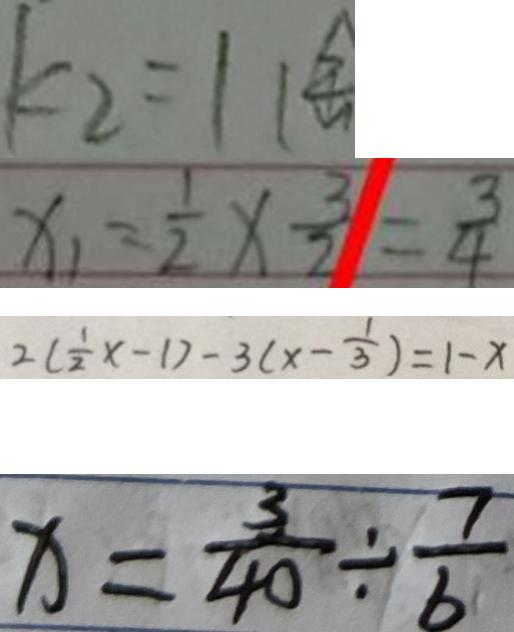<formula> <loc_0><loc_0><loc_500><loc_500>k _ { 2 } = 1 1 
 x _ { 1 } = \frac { 1 } { 2 } \times \frac { 3 } { 2 } = \frac { 3 } { 4 } 
 2 ( \frac { 1 } { 2 } x - 1 ) - 3 ( x - \frac { 1 } { 3 } ) = 1 - x 
 x = \frac { 3 } { 4 0 } \div \frac { 7 } { 6 }</formula> 